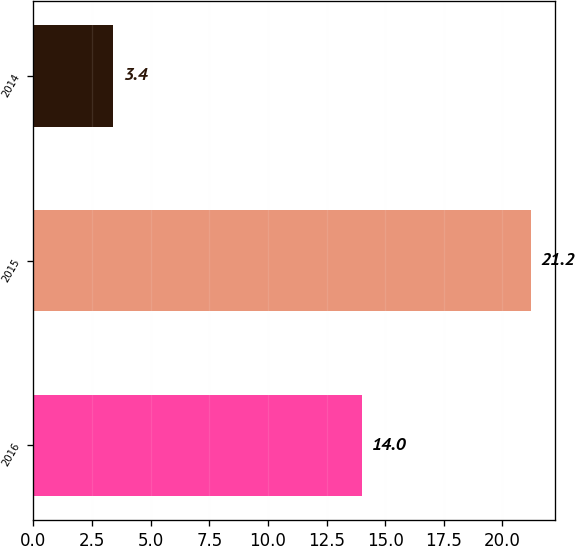<chart> <loc_0><loc_0><loc_500><loc_500><bar_chart><fcel>2016<fcel>2015<fcel>2014<nl><fcel>14<fcel>21.2<fcel>3.4<nl></chart> 